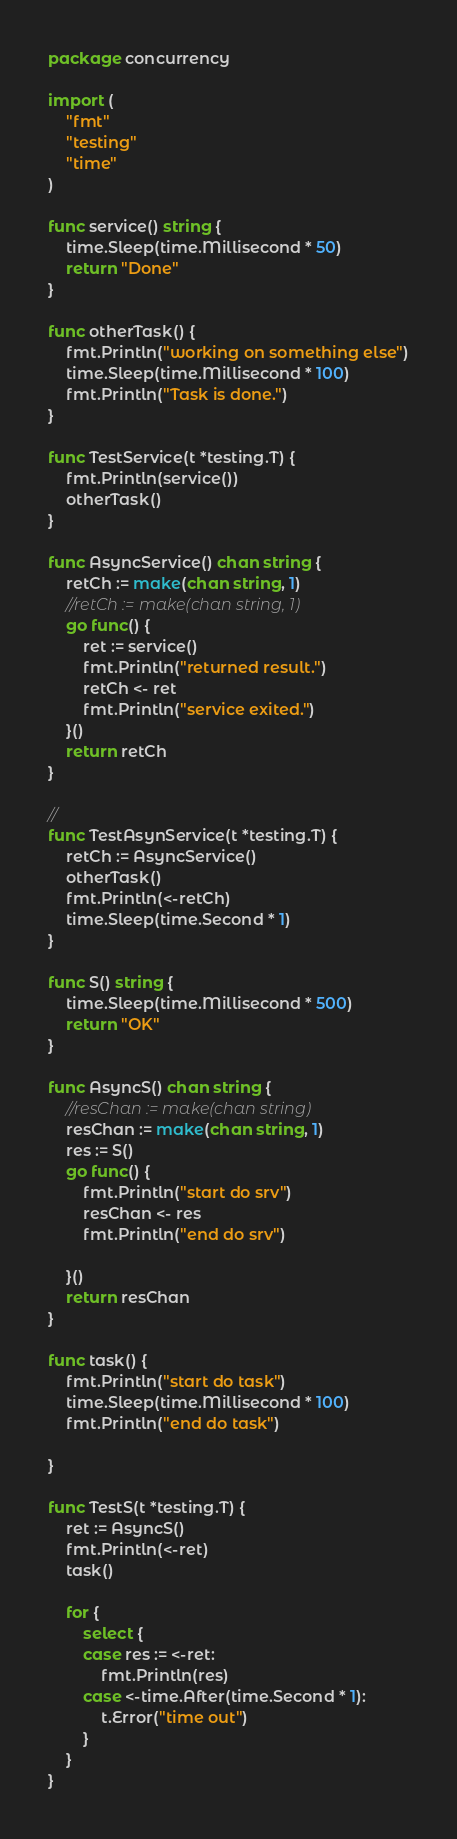Convert code to text. <code><loc_0><loc_0><loc_500><loc_500><_Go_>package concurrency

import (
	"fmt"
	"testing"
	"time"
)

func service() string {
	time.Sleep(time.Millisecond * 50)
	return "Done"
}

func otherTask() {
	fmt.Println("working on something else")
	time.Sleep(time.Millisecond * 100)
	fmt.Println("Task is done.")
}

func TestService(t *testing.T) {
	fmt.Println(service())
	otherTask()
}

func AsyncService() chan string {
	retCh := make(chan string, 1)
	//retCh := make(chan string, 1)
	go func() {
		ret := service()
		fmt.Println("returned result.")
		retCh <- ret
		fmt.Println("service exited.")
	}()
	return retCh
}

//
func TestAsynService(t *testing.T) {
	retCh := AsyncService()
	otherTask()
	fmt.Println(<-retCh)
	time.Sleep(time.Second * 1)
}

func S() string {
	time.Sleep(time.Millisecond * 500)
	return "OK"
}

func AsyncS() chan string {
	//resChan := make(chan string)
	resChan := make(chan string, 1)
	res := S()
	go func() {
		fmt.Println("start do srv")
		resChan <- res
		fmt.Println("end do srv")

	}()
	return resChan
}

func task() {
	fmt.Println("start do task")
	time.Sleep(time.Millisecond * 100)
	fmt.Println("end do task")

}

func TestS(t *testing.T) {
	ret := AsyncS()
	fmt.Println(<-ret)
	task()

	for {
		select {
		case res := <-ret:
			fmt.Println(res)
		case <-time.After(time.Second * 1):
			t.Error("time out")
		}
	}
}
</code> 